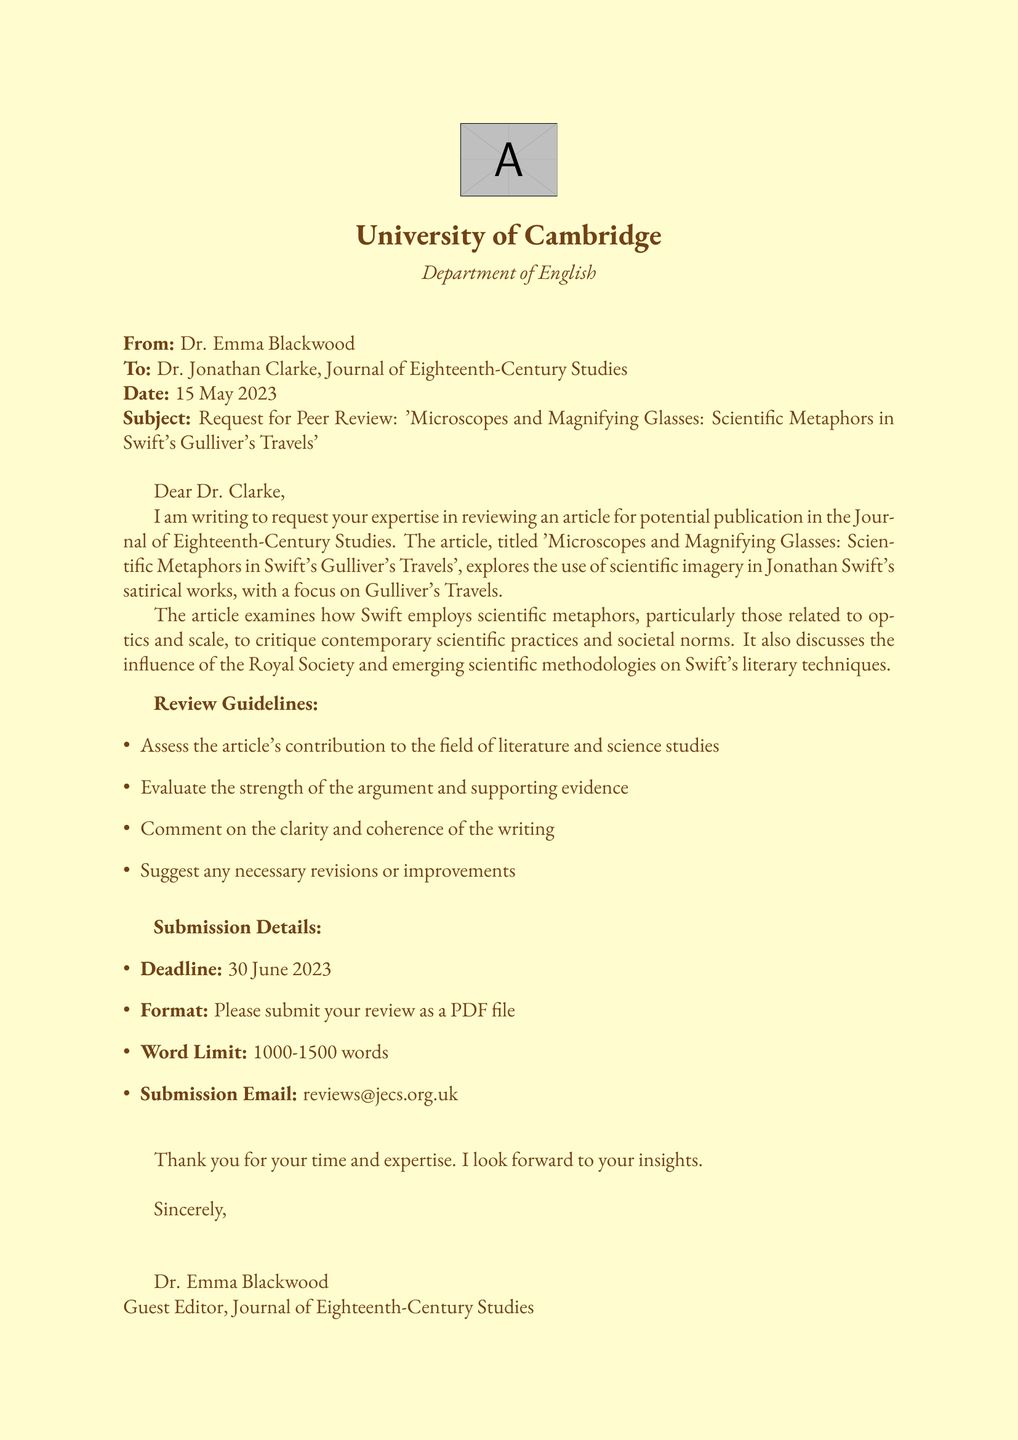What is the title of the article? The title is explicitly stated at the beginning of the document.
Answer: 'Microscopes and Magnifying Glasses: Scientific Metaphors in Swift's Gulliver's Travels' Who is the guest editor? The guest editor's name is mentioned in the closing of the document.
Answer: Dr. Emma Blackwood What is the deadline for the review submission? The deadline is clearly specified in the submission details section.
Answer: 30 June 2023 What is the word limit for the review? The word limit is stated in the submission details section.
Answer: 1000-1500 words What is one of the key focuses of the article? The article discusses specific themes related to the content of Swift's work.
Answer: Scientific imagery Who is the recipient of the request for peer review? The recipient's name is mentioned at the beginning of the document.
Answer: Dr. Jonathan Clarke What type of file should the review be submitted in? The file format for submission is indicated in the submission details.
Answer: PDF What journal is the article being reviewed for? The journal's name is noted in the header of the document.
Answer: Journal of Eighteenth-Century Studies What aspect does the review guidelines ask to evaluate? Review guidelines outline specific areas for critique in the article.
Answer: Strength of the argument 